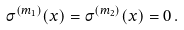<formula> <loc_0><loc_0><loc_500><loc_500>\sigma ^ { ( m _ { 1 } ) } ( x ) = \sigma ^ { ( m _ { 2 } ) } ( x ) = 0 \, .</formula> 